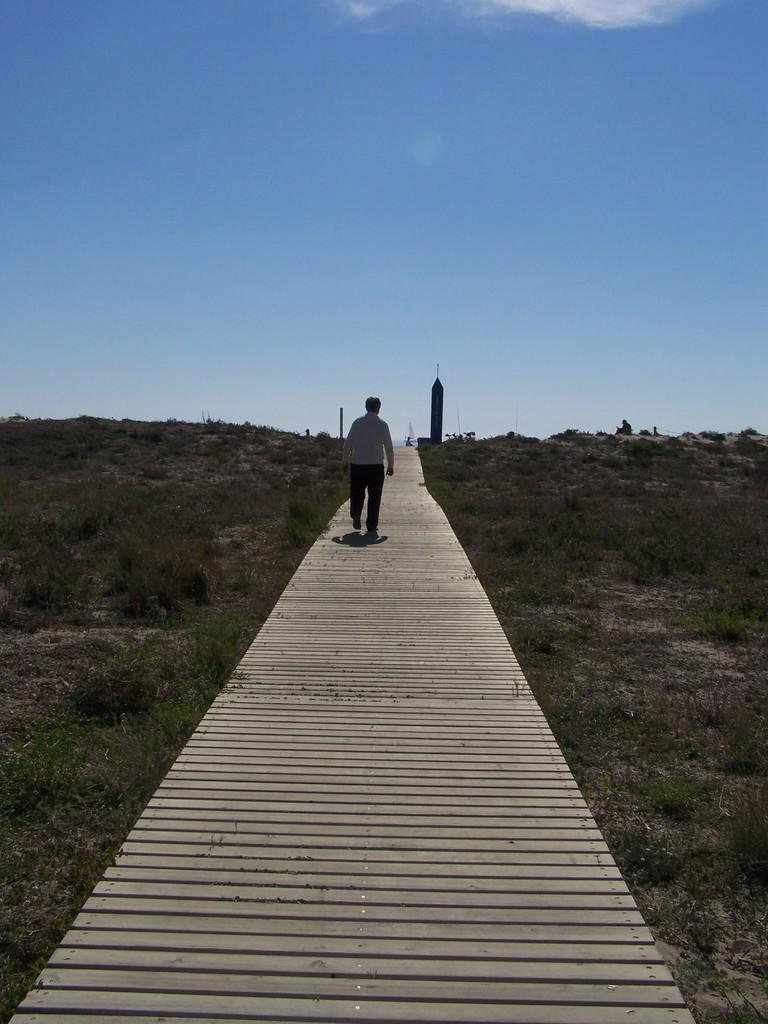What is the person in the image doing? The person is walking in the image. Where is the person walking? The person is walking on a path. What can be seen in the background of the image? There is a tower and a pole in the image, as well as grass and the sky. What type of soup is being cooked on the stove in the image? There is no stove or soup present in the image. Can you tell me how the person is using magic to walk in the image? There is no magic or indication of magical abilities in the image; the person is simply walking on a path. 